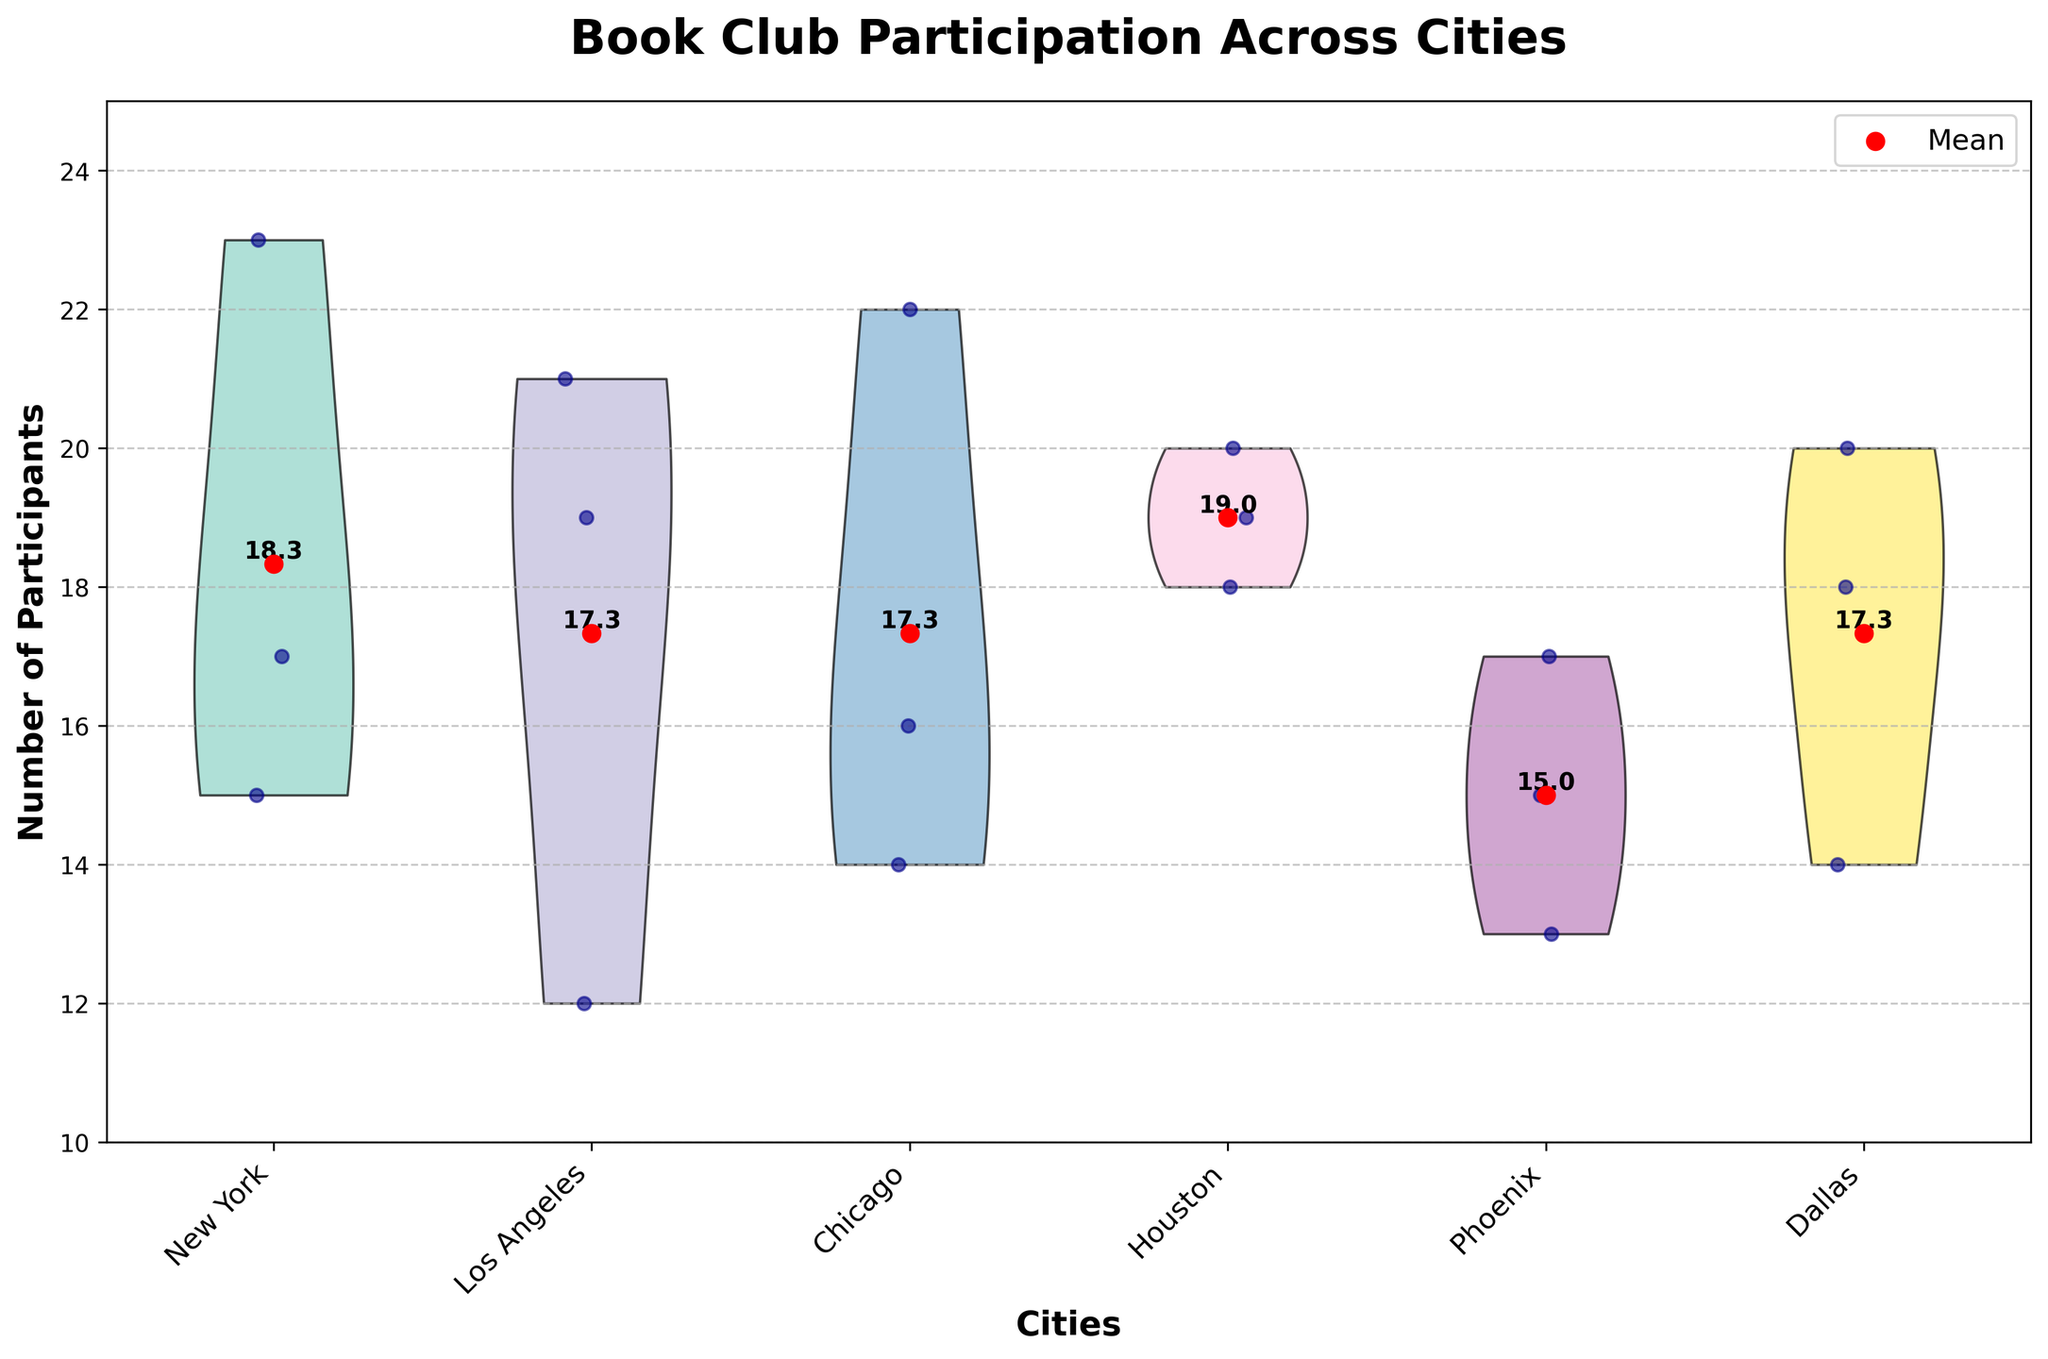What's the title of the plot? The title of the plot is shown at the top of the figure in a bold, large font. It reads 'Book Club Participation Across Cities'.
Answer: Book Club Participation Across Cities What city has the highest average number of participants? The average number of participants is marked by red points on each violin plot. To find the city with the highest average, compare the vertical positions of these red points.
Answer: New York Which city has the lowest median number of participants? Since there is no median line shown in the violin plot, we need to infer the median from the shape of the plot. The city with the lowest density around the midpoint likely has the smallest median.
Answer: Phoenix How many book clubs are plotted for Los Angeles? Look at the jittered points for Los Angeles. Each distinct point represents a book club. Counting these points indicates the number of book clubs.
Answer: 3 What is the range of participants in Chicago? The range is the difference between the maximum and minimum number of participants. Looking at the jittered points in the Chicago plot, identify the highest and lowest points. The lowest is 14 and the highest is 22. The range is, therefore, 22 - 14.
Answer: 8 Which city has the most tightly clustered participant data? A tightly clustered data set will have most of its points close together, with less spread. Look at the violin plots to see which one's width is the smallest.
Answer: Dallas Is the average participation higher in Houston or Phoenix? Compare the positions of the red mean points in the plots for Houston and Phoenix. The higher red point indicates the higher average.
Answer: Houston What is the average number of participants in New York? The average number of participants is marked by the red point in the New York plot. The number next to this point indicates the average value.
Answer: 18.3 